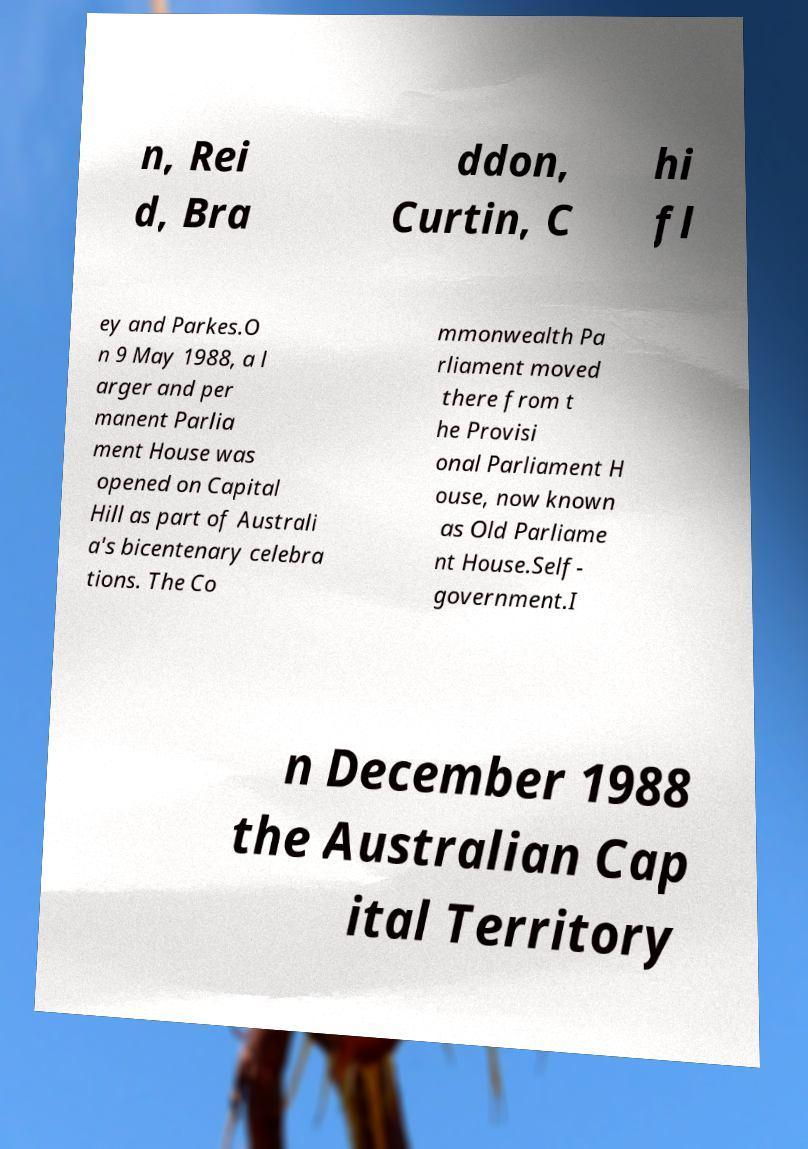Could you extract and type out the text from this image? n, Rei d, Bra ddon, Curtin, C hi fl ey and Parkes.O n 9 May 1988, a l arger and per manent Parlia ment House was opened on Capital Hill as part of Australi a's bicentenary celebra tions. The Co mmonwealth Pa rliament moved there from t he Provisi onal Parliament H ouse, now known as Old Parliame nt House.Self- government.I n December 1988 the Australian Cap ital Territory 